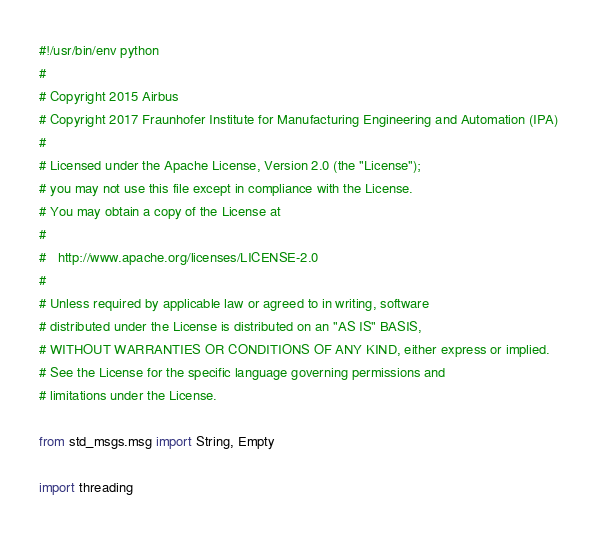Convert code to text. <code><loc_0><loc_0><loc_500><loc_500><_Python_>#!/usr/bin/env python
#
# Copyright 2015 Airbus
# Copyright 2017 Fraunhofer Institute for Manufacturing Engineering and Automation (IPA)
#
# Licensed under the Apache License, Version 2.0 (the "License");
# you may not use this file except in compliance with the License.
# You may obtain a copy of the License at
#
#   http://www.apache.org/licenses/LICENSE-2.0
#
# Unless required by applicable law or agreed to in writing, software
# distributed under the License is distributed on an "AS IS" BASIS,
# WITHOUT WARRANTIES OR CONDITIONS OF ANY KIND, either express or implied.
# See the License for the specific language governing permissions and
# limitations under the License.

from std_msgs.msg import String, Empty

import threading</code> 